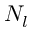<formula> <loc_0><loc_0><loc_500><loc_500>N _ { l }</formula> 